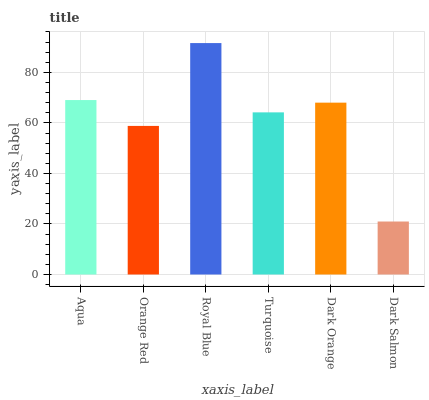Is Dark Salmon the minimum?
Answer yes or no. Yes. Is Royal Blue the maximum?
Answer yes or no. Yes. Is Orange Red the minimum?
Answer yes or no. No. Is Orange Red the maximum?
Answer yes or no. No. Is Aqua greater than Orange Red?
Answer yes or no. Yes. Is Orange Red less than Aqua?
Answer yes or no. Yes. Is Orange Red greater than Aqua?
Answer yes or no. No. Is Aqua less than Orange Red?
Answer yes or no. No. Is Dark Orange the high median?
Answer yes or no. Yes. Is Turquoise the low median?
Answer yes or no. Yes. Is Orange Red the high median?
Answer yes or no. No. Is Orange Red the low median?
Answer yes or no. No. 